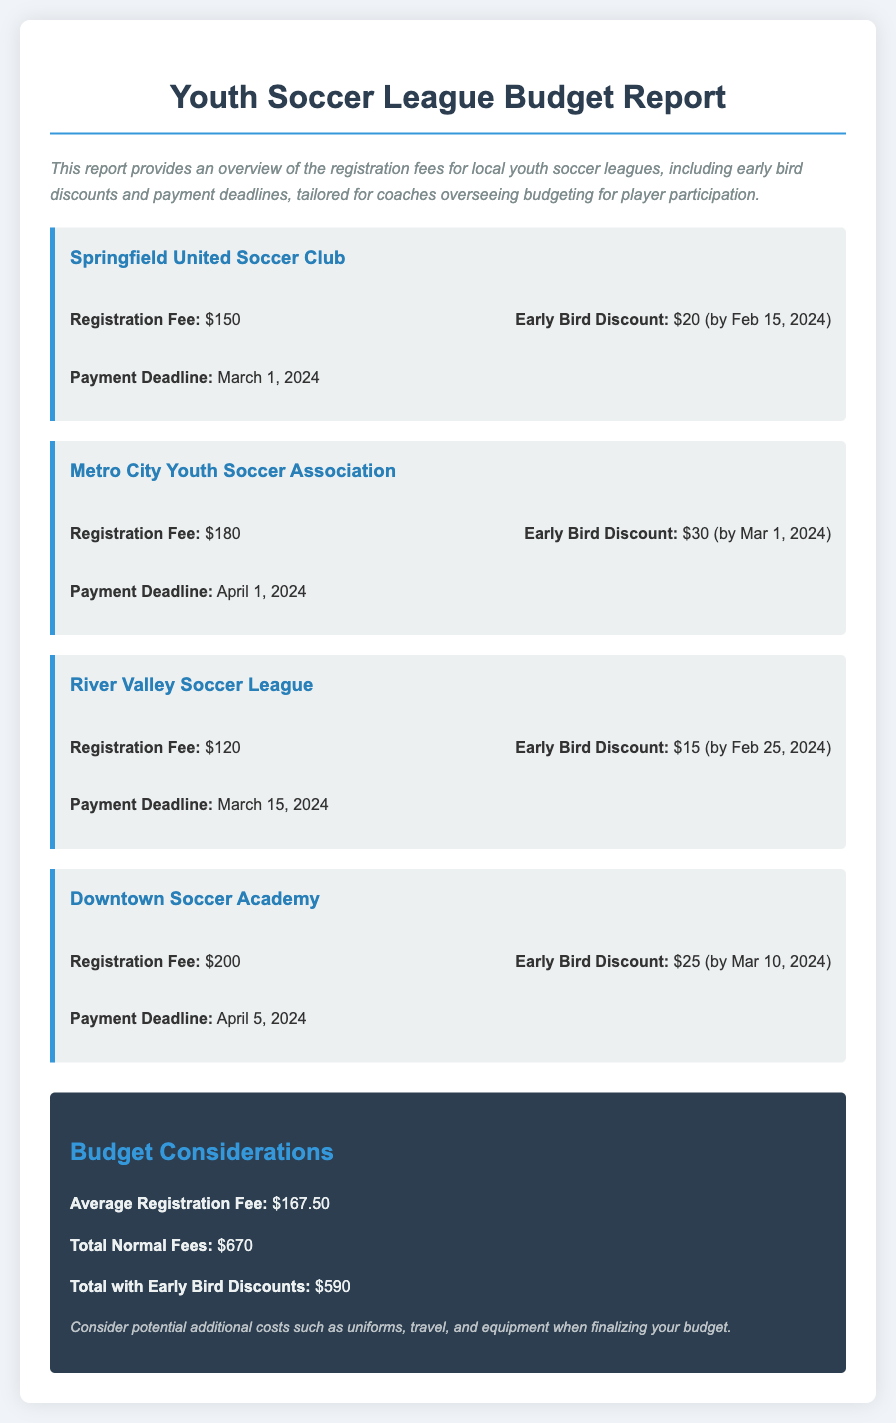What is the registration fee for Springfield United Soccer Club? The registration fee for Springfield United Soccer Club is specified under that league section, which is $150.
Answer: $150 What is the early bird discount amount for Metro City Youth Soccer Association? The early bird discount amount is found in the fee information for that league, which is $30.
Answer: $30 When is the payment deadline for River Valley Soccer League? The payment deadline is listed directly under the league's details, which is March 15, 2024.
Answer: March 15, 2024 What is the average registration fee across all leagues? The average registration fee is calculated from the provided fees in the budget summary section, which is $167.50.
Answer: $167.50 What is the total normal fees for all leagues combined? The total normal fees are found in the budget summary and is the sum of all registration fees, which is $670.
Answer: $670 How much can be saved with early bird discounts across all leagues? This requires comparing the total normal fees with total fees after discounts, which is a reduction of $80.
Answer: $80 What is the early bird discount deadline for Downtown Soccer Academy? The early bird discount deadline is captured in the league's fee information, which is by March 10, 2024.
Answer: March 10, 2024 What is the registration fee for the cheapest league? The cheapest registration fee is noted within the leagues, which is $120 for River Valley Soccer League.
Answer: $120 